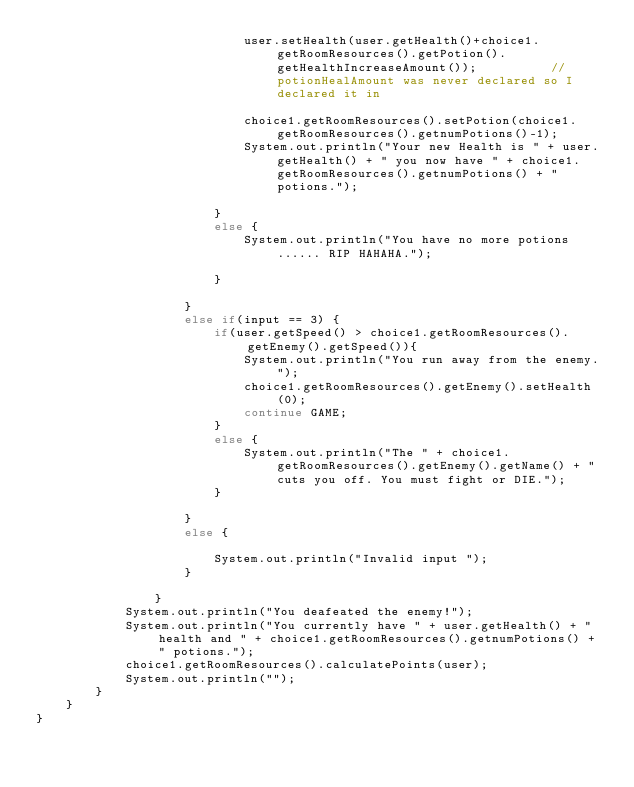<code> <loc_0><loc_0><loc_500><loc_500><_Java_>							user.setHealth(user.getHealth()+choice1.getRoomResources().getPotion().getHealthIncreaseAmount());			// potionHealAmount was never declared so I declared it in 
							
							choice1.getRoomResources().setPotion(choice1.getRoomResources().getnumPotions()-1);
							System.out.println("Your new Health is " + user.getHealth() + " you now have " + choice1.getRoomResources().getnumPotions() + " potions.");
							
						}
						else {
							System.out.println("You have no more potions...... RIP HAHAHA.");
							
						}
						
					}
					else if(input == 3) {
						if(user.getSpeed() > choice1.getRoomResources().getEnemy().getSpeed()){
							System.out.println("You run away from the enemy. ");
							choice1.getRoomResources().getEnemy().setHealth(0);
							continue GAME;
						}
						else {
							System.out.println("The " + choice1.getRoomResources().getEnemy().getName() + " cuts you off. You must fight or DIE.");
						}
						
					}
					else {
					
						System.out.println("Invalid input ");
					}
					
				}
			System.out.println("You deafeated the enemy!");
			System.out.println("You currently have " + user.getHealth() + " health and " + choice1.getRoomResources().getnumPotions() + " potions.");
			choice1.getRoomResources().calculatePoints(user);
			System.out.println("");
		}
	}
}




	
	
			
	


</code> 